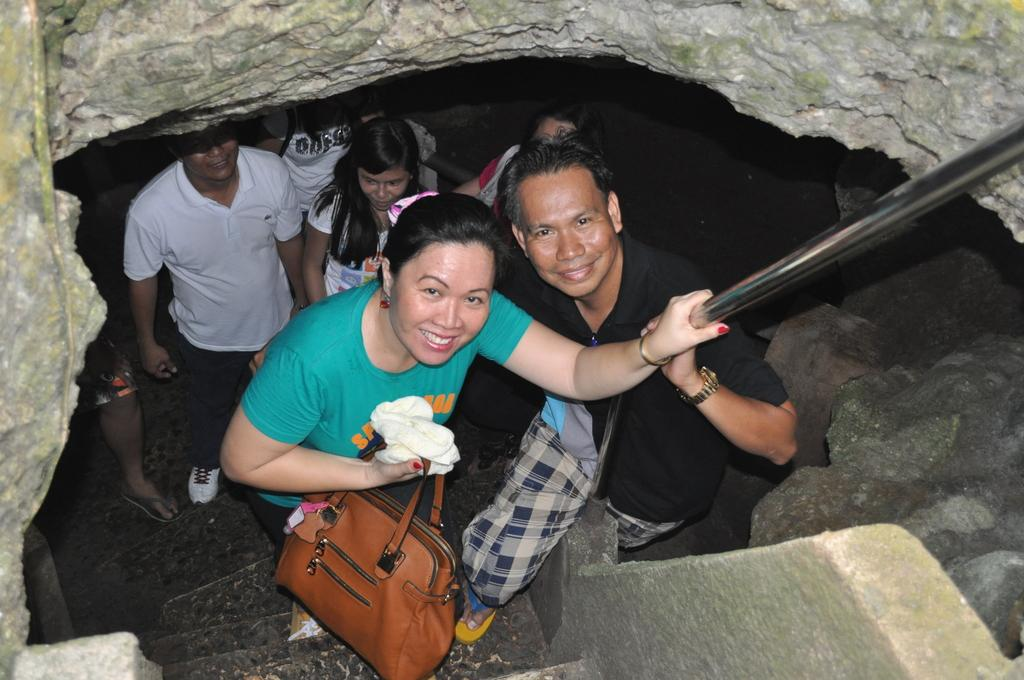What is happening in the image? There are people standing in the image. Can you describe the expressions on the people's faces? Some people in the image are smiling. What object is being held by one of the people? A person is holding a brown handbag. How many trees can be seen in the image? There are no trees visible in the image; it only shows people standing and smiling. What type of drawer is being used by the person holding the handbag? There is no drawer present in the image; it only shows people standing and smiling, and one person holding a brown handbag. 